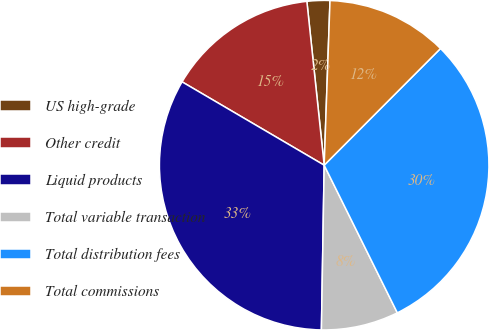Convert chart to OTSL. <chart><loc_0><loc_0><loc_500><loc_500><pie_chart><fcel>US high-grade<fcel>Other credit<fcel>Liquid products<fcel>Total variable transaction<fcel>Total distribution fees<fcel>Total commissions<nl><fcel>2.24%<fcel>14.88%<fcel>33.17%<fcel>7.59%<fcel>30.2%<fcel>11.91%<nl></chart> 